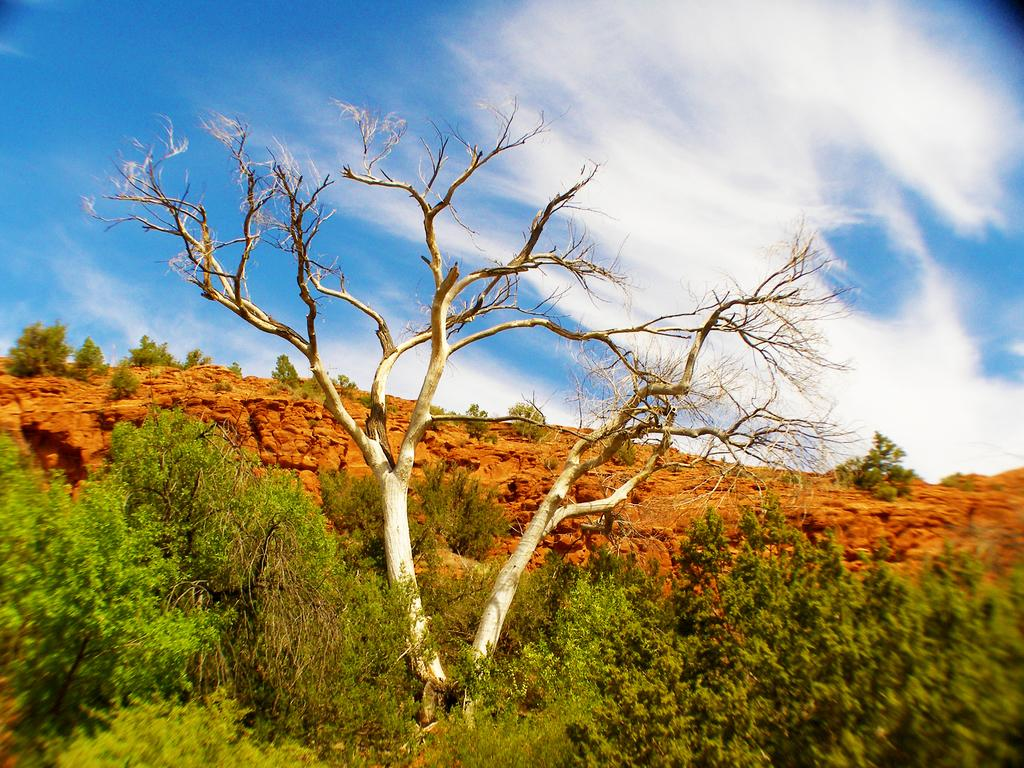What type of vegetation can be seen in the image? There are trees in the image. What is visible in the background of the image? The sky is visible in the background of the image. What can be observed in the sky? Clouds are present in the sky. What type of wine is being served in the image? There is no wine present in the image; it features trees and clouds in the sky. How many potatoes can be seen in the image? There are no potatoes present in the image. 